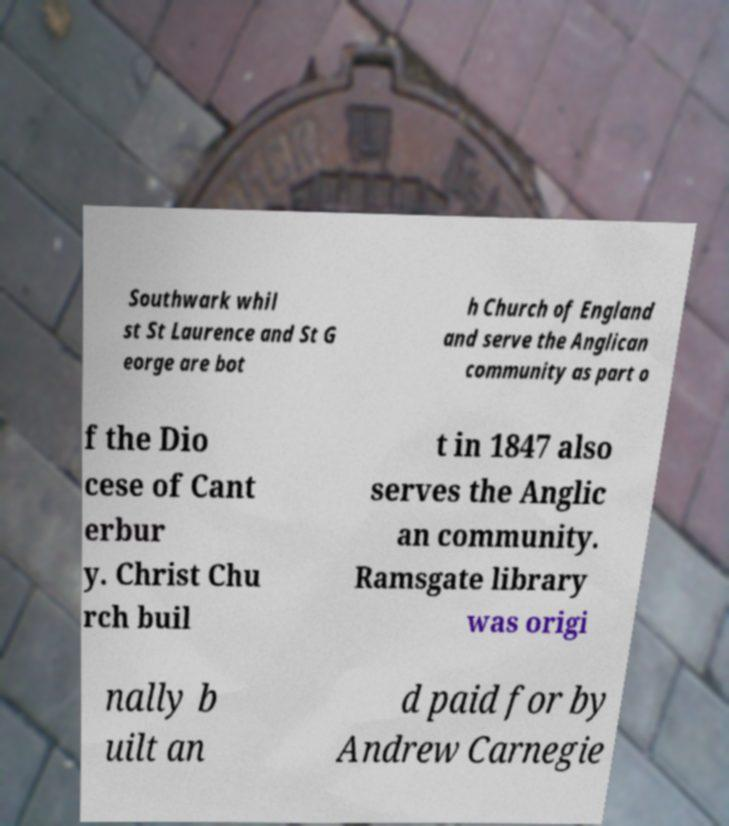Could you extract and type out the text from this image? Southwark whil st St Laurence and St G eorge are bot h Church of England and serve the Anglican community as part o f the Dio cese of Cant erbur y. Christ Chu rch buil t in 1847 also serves the Anglic an community. Ramsgate library was origi nally b uilt an d paid for by Andrew Carnegie 